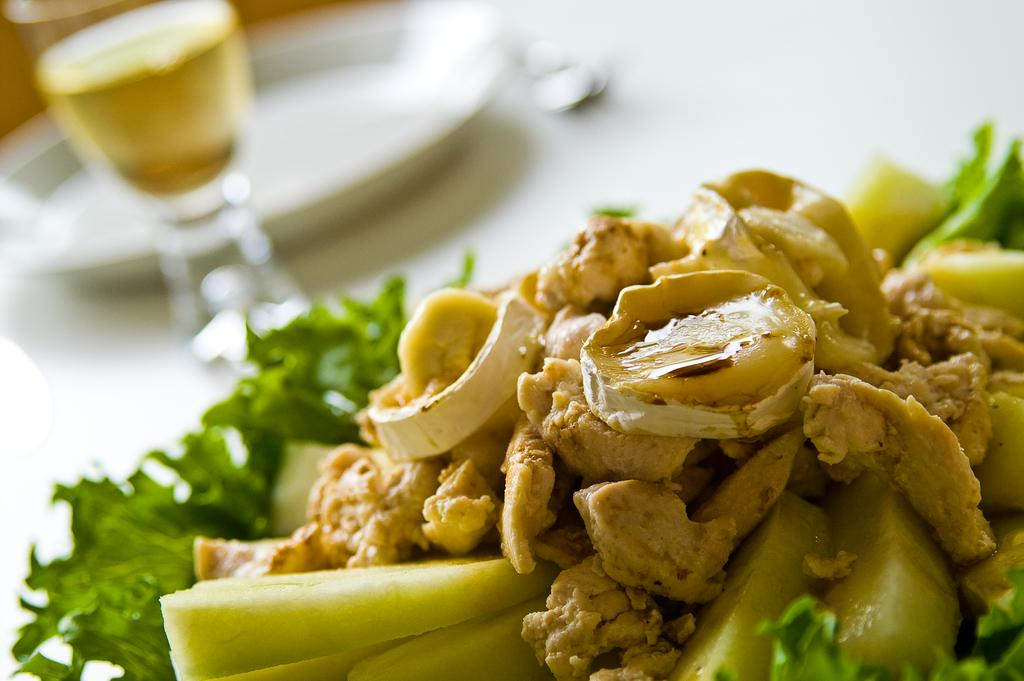What type of food items can be seen in the image? There are food items with green leafy vegetables in the image. What type of container is present in the image? There is a glass in the image. What type of dishware is present in the image? There is a plate in the image. What type of utensil is present in the image? There is a spoon in the image. Where are these items located in the image? These items are on a table. Can you ask the expert for help in identifying the type of oil used in the food items? There is no expert or mention of oil in the image, so we cannot ask for help in identifying the type of oil used. 